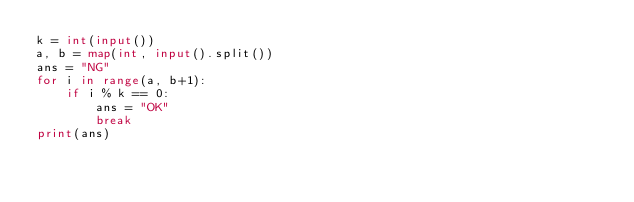Convert code to text. <code><loc_0><loc_0><loc_500><loc_500><_Python_>k = int(input())
a, b = map(int, input().split())
ans = "NG"
for i in range(a, b+1):
    if i % k == 0:
        ans = "OK"
        break
print(ans)
</code> 